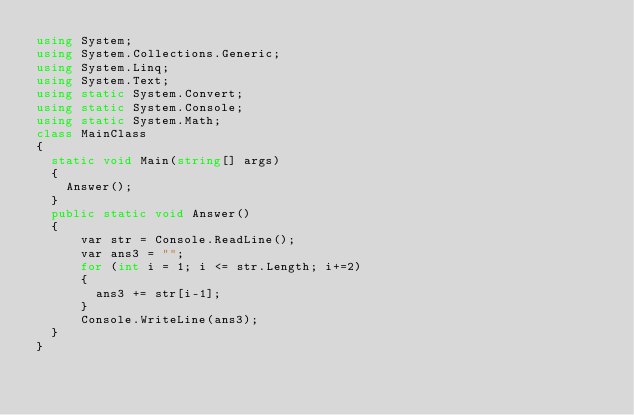Convert code to text. <code><loc_0><loc_0><loc_500><loc_500><_C#_>using System;
using System.Collections.Generic;
using System.Linq;
using System.Text;
using static System.Convert;
using static System.Console;
using static System.Math;
class MainClass
{
	static void Main(string[] args)
	{
		Answer();
	}
	public static void Answer()
	{
      var str = Console.ReadLine();
      var ans3 = "";
      for (int i = 1; i <= str.Length; i+=2)
      {
        ans3 += str[i-1];
      }
      Console.WriteLine(ans3);
	}
}
</code> 